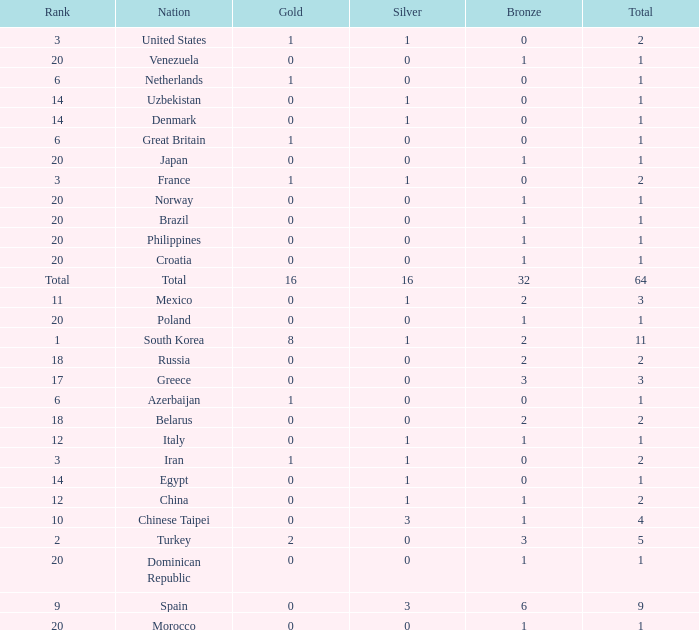What is the average total medals of the nation ranked 1 with less than 1 silver? None. 